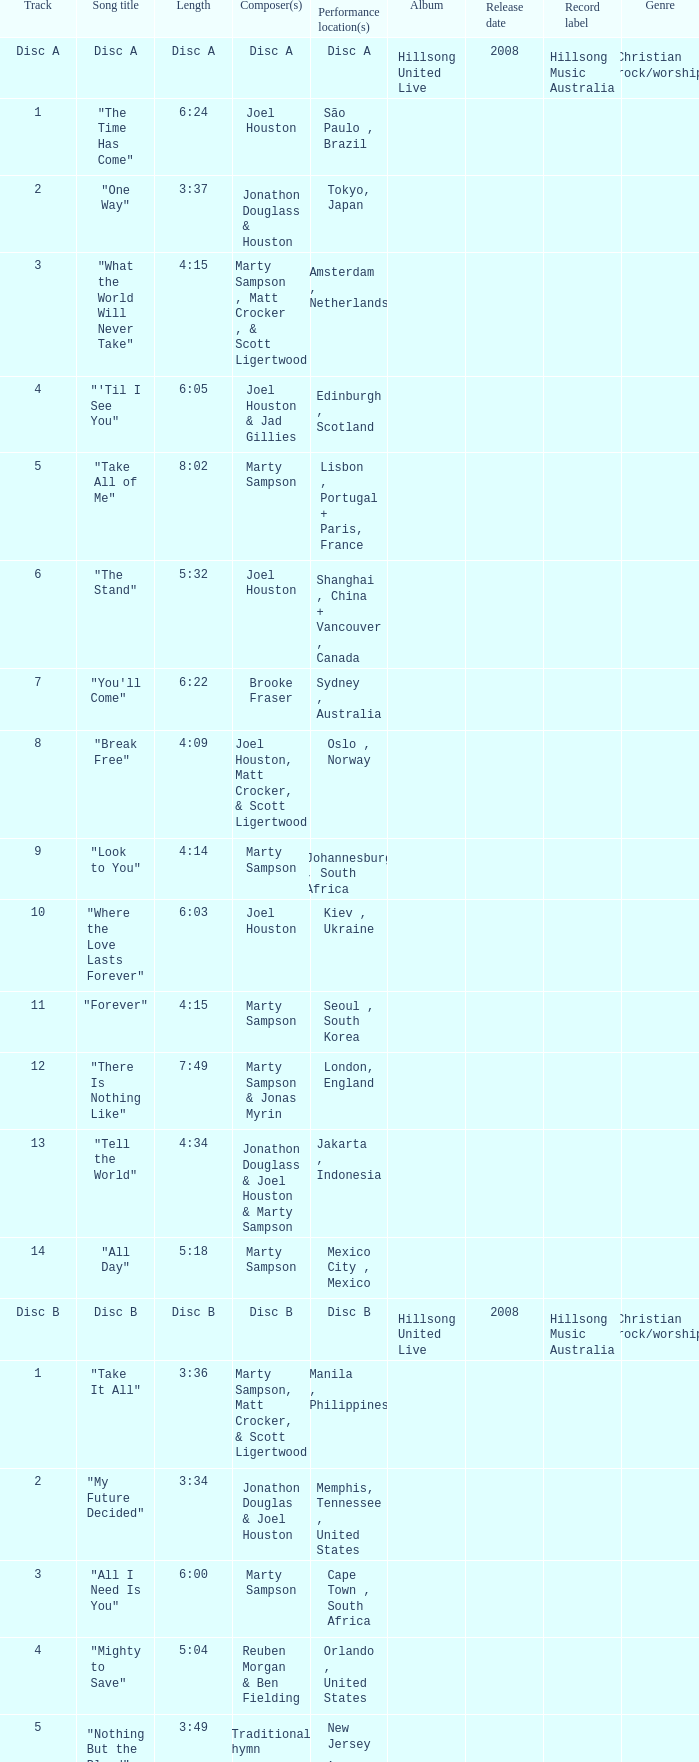What is the lengtho f track 16? 5:55. 